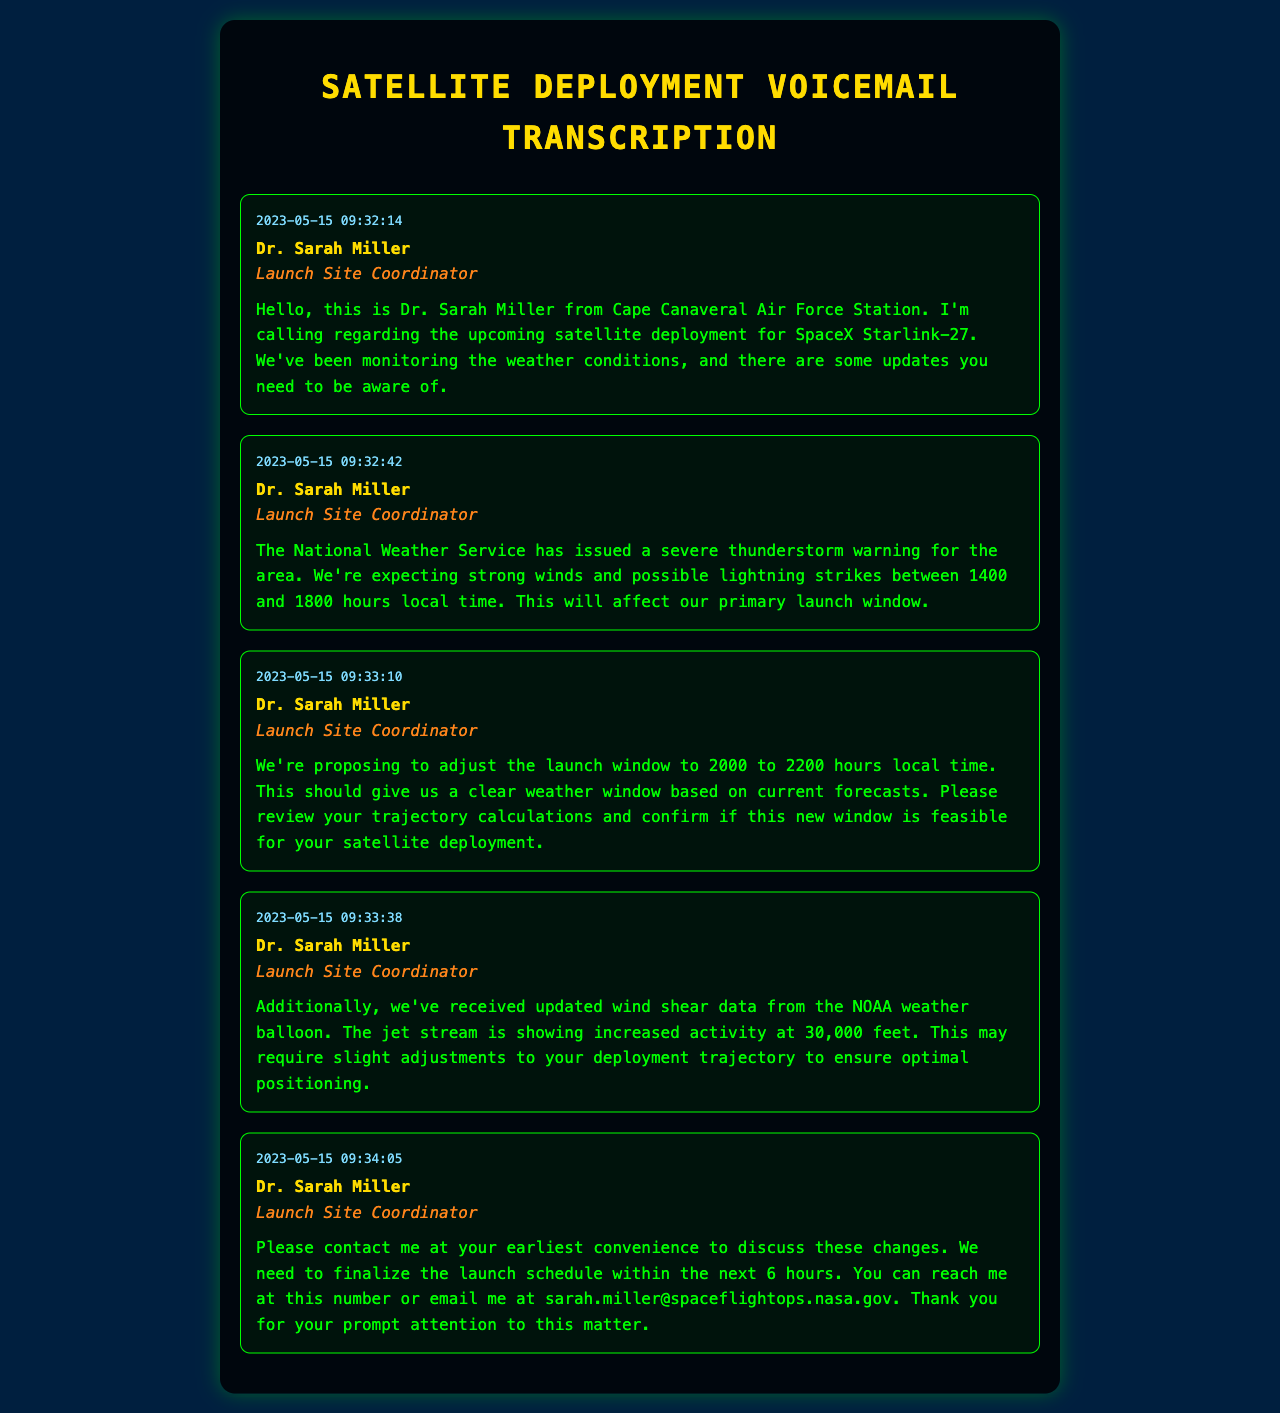What is the date of the voicemail? The date is indicated in the timestamp of the first voicemail, which is 2023-05-15.
Answer: 2023-05-15 Who is the caller? The caller's name is presented in each voicemail, identified as Dr. Sarah Miller.
Answer: Dr. Sarah Miller What severe weather event is mentioned? The voicemail indicates that the National Weather Service has issued a severe thunderstorm warning.
Answer: Severe thunderstorm warning What time is the proposed adjustment for the launch window? The proposed adjustment is mentioned in the third voicemail, stating a new window from 2000 to 2200 hours local time.
Answer: 2000 to 2200 hours What is the altitude at which increased jet stream activity is reported? The voicemail specifies that increased activity is detected at 30,000 feet.
Answer: 30,000 feet How long do they need to finalize the launch schedule? The finalization time is mentioned as needing to occur within the next 6 hours.
Answer: 6 hours What is the main purpose of this voicemail record? The main purpose is to communicate weather conditions and proposed adjustments to the satellite launch schedule.
Answer: Communication of weather and launch adjustments What action does Dr. Sarah Miller request at the end of her message? The voicemail requests the listener to contact her to discuss changes.
Answer: Contact her to discuss changes 